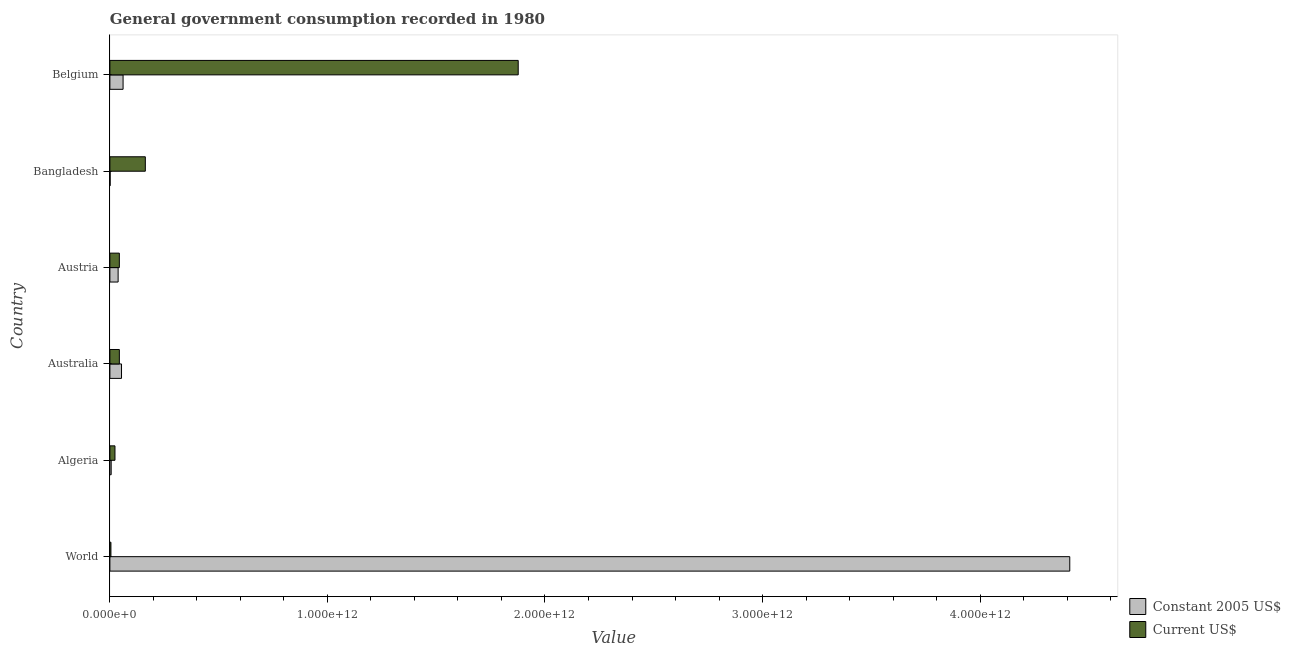How many groups of bars are there?
Keep it short and to the point. 6. How many bars are there on the 2nd tick from the bottom?
Give a very brief answer. 2. What is the label of the 2nd group of bars from the top?
Make the answer very short. Bangladesh. In how many cases, is the number of bars for a given country not equal to the number of legend labels?
Provide a succinct answer. 0. What is the value consumed in current us$ in Algeria?
Your answer should be compact. 2.34e+1. Across all countries, what is the maximum value consumed in constant 2005 us$?
Keep it short and to the point. 4.41e+12. Across all countries, what is the minimum value consumed in current us$?
Your response must be concise. 4.76e+09. In which country was the value consumed in constant 2005 us$ minimum?
Your answer should be compact. Bangladesh. What is the total value consumed in constant 2005 us$ in the graph?
Your answer should be compact. 4.57e+12. What is the difference between the value consumed in current us$ in Austria and that in World?
Provide a short and direct response. 3.87e+1. What is the difference between the value consumed in constant 2005 us$ in Bangladesh and the value consumed in current us$ in Austria?
Ensure brevity in your answer.  -4.23e+1. What is the average value consumed in current us$ per country?
Keep it short and to the point. 3.59e+11. What is the difference between the value consumed in constant 2005 us$ and value consumed in current us$ in Austria?
Keep it short and to the point. -5.59e+09. In how many countries, is the value consumed in constant 2005 us$ greater than 2400000000000 ?
Give a very brief answer. 1. Is the difference between the value consumed in current us$ in Algeria and Belgium greater than the difference between the value consumed in constant 2005 us$ in Algeria and Belgium?
Make the answer very short. No. What is the difference between the highest and the second highest value consumed in current us$?
Your response must be concise. 1.71e+12. What is the difference between the highest and the lowest value consumed in constant 2005 us$?
Your answer should be compact. 4.41e+12. In how many countries, is the value consumed in constant 2005 us$ greater than the average value consumed in constant 2005 us$ taken over all countries?
Ensure brevity in your answer.  1. Is the sum of the value consumed in constant 2005 us$ in Austria and World greater than the maximum value consumed in current us$ across all countries?
Offer a very short reply. Yes. What does the 2nd bar from the top in Belgium represents?
Give a very brief answer. Constant 2005 US$. What does the 1st bar from the bottom in Belgium represents?
Your response must be concise. Constant 2005 US$. How many bars are there?
Provide a succinct answer. 12. What is the difference between two consecutive major ticks on the X-axis?
Offer a terse response. 1.00e+12. Are the values on the major ticks of X-axis written in scientific E-notation?
Offer a terse response. Yes. Does the graph contain any zero values?
Your answer should be very brief. No. Where does the legend appear in the graph?
Ensure brevity in your answer.  Bottom right. How many legend labels are there?
Keep it short and to the point. 2. How are the legend labels stacked?
Provide a short and direct response. Vertical. What is the title of the graph?
Make the answer very short. General government consumption recorded in 1980. What is the label or title of the X-axis?
Offer a terse response. Value. What is the label or title of the Y-axis?
Keep it short and to the point. Country. What is the Value in Constant 2005 US$ in World?
Offer a very short reply. 4.41e+12. What is the Value of Current US$ in World?
Provide a short and direct response. 4.76e+09. What is the Value of Constant 2005 US$ in Algeria?
Offer a very short reply. 5.88e+09. What is the Value of Current US$ in Algeria?
Offer a very short reply. 2.34e+1. What is the Value of Constant 2005 US$ in Australia?
Offer a very short reply. 5.34e+1. What is the Value of Current US$ in Australia?
Make the answer very short. 4.35e+1. What is the Value of Constant 2005 US$ in Austria?
Provide a succinct answer. 3.78e+1. What is the Value of Current US$ in Austria?
Keep it short and to the point. 4.34e+1. What is the Value in Constant 2005 US$ in Bangladesh?
Make the answer very short. 1.09e+09. What is the Value of Current US$ in Bangladesh?
Your answer should be very brief. 1.63e+11. What is the Value of Constant 2005 US$ in Belgium?
Your answer should be compact. 6.06e+1. What is the Value in Current US$ in Belgium?
Offer a terse response. 1.88e+12. Across all countries, what is the maximum Value in Constant 2005 US$?
Your answer should be very brief. 4.41e+12. Across all countries, what is the maximum Value of Current US$?
Offer a very short reply. 1.88e+12. Across all countries, what is the minimum Value in Constant 2005 US$?
Keep it short and to the point. 1.09e+09. Across all countries, what is the minimum Value of Current US$?
Make the answer very short. 4.76e+09. What is the total Value in Constant 2005 US$ in the graph?
Offer a very short reply. 4.57e+12. What is the total Value in Current US$ in the graph?
Make the answer very short. 2.15e+12. What is the difference between the Value of Constant 2005 US$ in World and that in Algeria?
Provide a short and direct response. 4.41e+12. What is the difference between the Value of Current US$ in World and that in Algeria?
Keep it short and to the point. -1.86e+1. What is the difference between the Value of Constant 2005 US$ in World and that in Australia?
Make the answer very short. 4.36e+12. What is the difference between the Value of Current US$ in World and that in Australia?
Make the answer very short. -3.87e+1. What is the difference between the Value in Constant 2005 US$ in World and that in Austria?
Your answer should be very brief. 4.37e+12. What is the difference between the Value of Current US$ in World and that in Austria?
Provide a succinct answer. -3.87e+1. What is the difference between the Value of Constant 2005 US$ in World and that in Bangladesh?
Make the answer very short. 4.41e+12. What is the difference between the Value of Current US$ in World and that in Bangladesh?
Provide a succinct answer. -1.58e+11. What is the difference between the Value of Constant 2005 US$ in World and that in Belgium?
Offer a very short reply. 4.35e+12. What is the difference between the Value of Current US$ in World and that in Belgium?
Provide a succinct answer. -1.87e+12. What is the difference between the Value in Constant 2005 US$ in Algeria and that in Australia?
Your answer should be very brief. -4.75e+1. What is the difference between the Value in Current US$ in Algeria and that in Australia?
Offer a very short reply. -2.01e+1. What is the difference between the Value of Constant 2005 US$ in Algeria and that in Austria?
Offer a very short reply. -3.20e+1. What is the difference between the Value of Current US$ in Algeria and that in Austria?
Offer a very short reply. -2.01e+1. What is the difference between the Value in Constant 2005 US$ in Algeria and that in Bangladesh?
Offer a terse response. 4.78e+09. What is the difference between the Value in Current US$ in Algeria and that in Bangladesh?
Offer a very short reply. -1.40e+11. What is the difference between the Value of Constant 2005 US$ in Algeria and that in Belgium?
Make the answer very short. -5.47e+1. What is the difference between the Value of Current US$ in Algeria and that in Belgium?
Provide a short and direct response. -1.85e+12. What is the difference between the Value of Constant 2005 US$ in Australia and that in Austria?
Your answer should be very brief. 1.56e+1. What is the difference between the Value of Current US$ in Australia and that in Austria?
Offer a terse response. 6.97e+07. What is the difference between the Value of Constant 2005 US$ in Australia and that in Bangladesh?
Your answer should be very brief. 5.23e+1. What is the difference between the Value of Current US$ in Australia and that in Bangladesh?
Offer a very short reply. -1.19e+11. What is the difference between the Value in Constant 2005 US$ in Australia and that in Belgium?
Offer a terse response. -7.18e+09. What is the difference between the Value in Current US$ in Australia and that in Belgium?
Offer a very short reply. -1.83e+12. What is the difference between the Value in Constant 2005 US$ in Austria and that in Bangladesh?
Provide a short and direct response. 3.67e+1. What is the difference between the Value in Current US$ in Austria and that in Bangladesh?
Make the answer very short. -1.19e+11. What is the difference between the Value of Constant 2005 US$ in Austria and that in Belgium?
Your answer should be very brief. -2.27e+1. What is the difference between the Value of Current US$ in Austria and that in Belgium?
Give a very brief answer. -1.83e+12. What is the difference between the Value of Constant 2005 US$ in Bangladesh and that in Belgium?
Keep it short and to the point. -5.95e+1. What is the difference between the Value of Current US$ in Bangladesh and that in Belgium?
Your answer should be compact. -1.71e+12. What is the difference between the Value of Constant 2005 US$ in World and the Value of Current US$ in Algeria?
Your response must be concise. 4.39e+12. What is the difference between the Value in Constant 2005 US$ in World and the Value in Current US$ in Australia?
Your answer should be compact. 4.37e+12. What is the difference between the Value of Constant 2005 US$ in World and the Value of Current US$ in Austria?
Provide a short and direct response. 4.37e+12. What is the difference between the Value of Constant 2005 US$ in World and the Value of Current US$ in Bangladesh?
Make the answer very short. 4.25e+12. What is the difference between the Value in Constant 2005 US$ in World and the Value in Current US$ in Belgium?
Your answer should be very brief. 2.54e+12. What is the difference between the Value of Constant 2005 US$ in Algeria and the Value of Current US$ in Australia?
Give a very brief answer. -3.76e+1. What is the difference between the Value of Constant 2005 US$ in Algeria and the Value of Current US$ in Austria?
Your response must be concise. -3.76e+1. What is the difference between the Value in Constant 2005 US$ in Algeria and the Value in Current US$ in Bangladesh?
Ensure brevity in your answer.  -1.57e+11. What is the difference between the Value of Constant 2005 US$ in Algeria and the Value of Current US$ in Belgium?
Give a very brief answer. -1.87e+12. What is the difference between the Value of Constant 2005 US$ in Australia and the Value of Current US$ in Austria?
Provide a succinct answer. 9.97e+09. What is the difference between the Value in Constant 2005 US$ in Australia and the Value in Current US$ in Bangladesh?
Make the answer very short. -1.09e+11. What is the difference between the Value of Constant 2005 US$ in Australia and the Value of Current US$ in Belgium?
Your answer should be very brief. -1.82e+12. What is the difference between the Value in Constant 2005 US$ in Austria and the Value in Current US$ in Bangladesh?
Offer a terse response. -1.25e+11. What is the difference between the Value of Constant 2005 US$ in Austria and the Value of Current US$ in Belgium?
Offer a very short reply. -1.84e+12. What is the difference between the Value in Constant 2005 US$ in Bangladesh and the Value in Current US$ in Belgium?
Your response must be concise. -1.88e+12. What is the average Value in Constant 2005 US$ per country?
Your answer should be very brief. 7.62e+11. What is the average Value in Current US$ per country?
Your answer should be compact. 3.59e+11. What is the difference between the Value of Constant 2005 US$ and Value of Current US$ in World?
Ensure brevity in your answer.  4.41e+12. What is the difference between the Value in Constant 2005 US$ and Value in Current US$ in Algeria?
Make the answer very short. -1.75e+1. What is the difference between the Value of Constant 2005 US$ and Value of Current US$ in Australia?
Make the answer very short. 9.90e+09. What is the difference between the Value of Constant 2005 US$ and Value of Current US$ in Austria?
Your response must be concise. -5.59e+09. What is the difference between the Value of Constant 2005 US$ and Value of Current US$ in Bangladesh?
Your response must be concise. -1.62e+11. What is the difference between the Value of Constant 2005 US$ and Value of Current US$ in Belgium?
Your response must be concise. -1.82e+12. What is the ratio of the Value in Constant 2005 US$ in World to that in Algeria?
Your answer should be compact. 750.75. What is the ratio of the Value of Current US$ in World to that in Algeria?
Make the answer very short. 0.2. What is the ratio of the Value of Constant 2005 US$ in World to that in Australia?
Your answer should be compact. 82.63. What is the ratio of the Value of Current US$ in World to that in Australia?
Offer a terse response. 0.11. What is the ratio of the Value in Constant 2005 US$ in World to that in Austria?
Keep it short and to the point. 116.62. What is the ratio of the Value in Current US$ in World to that in Austria?
Your answer should be very brief. 0.11. What is the ratio of the Value of Constant 2005 US$ in World to that in Bangladesh?
Your response must be concise. 4035.72. What is the ratio of the Value in Current US$ in World to that in Bangladesh?
Offer a terse response. 0.03. What is the ratio of the Value of Constant 2005 US$ in World to that in Belgium?
Keep it short and to the point. 72.83. What is the ratio of the Value in Current US$ in World to that in Belgium?
Offer a terse response. 0. What is the ratio of the Value in Constant 2005 US$ in Algeria to that in Australia?
Your answer should be compact. 0.11. What is the ratio of the Value in Current US$ in Algeria to that in Australia?
Your response must be concise. 0.54. What is the ratio of the Value in Constant 2005 US$ in Algeria to that in Austria?
Your response must be concise. 0.16. What is the ratio of the Value in Current US$ in Algeria to that in Austria?
Make the answer very short. 0.54. What is the ratio of the Value of Constant 2005 US$ in Algeria to that in Bangladesh?
Provide a short and direct response. 5.38. What is the ratio of the Value of Current US$ in Algeria to that in Bangladesh?
Your answer should be very brief. 0.14. What is the ratio of the Value of Constant 2005 US$ in Algeria to that in Belgium?
Your response must be concise. 0.1. What is the ratio of the Value in Current US$ in Algeria to that in Belgium?
Your answer should be very brief. 0.01. What is the ratio of the Value in Constant 2005 US$ in Australia to that in Austria?
Provide a succinct answer. 1.41. What is the ratio of the Value in Constant 2005 US$ in Australia to that in Bangladesh?
Your answer should be very brief. 48.84. What is the ratio of the Value of Current US$ in Australia to that in Bangladesh?
Your answer should be compact. 0.27. What is the ratio of the Value of Constant 2005 US$ in Australia to that in Belgium?
Ensure brevity in your answer.  0.88. What is the ratio of the Value in Current US$ in Australia to that in Belgium?
Keep it short and to the point. 0.02. What is the ratio of the Value in Constant 2005 US$ in Austria to that in Bangladesh?
Provide a succinct answer. 34.61. What is the ratio of the Value in Current US$ in Austria to that in Bangladesh?
Ensure brevity in your answer.  0.27. What is the ratio of the Value in Constant 2005 US$ in Austria to that in Belgium?
Offer a terse response. 0.62. What is the ratio of the Value in Current US$ in Austria to that in Belgium?
Make the answer very short. 0.02. What is the ratio of the Value in Constant 2005 US$ in Bangladesh to that in Belgium?
Provide a succinct answer. 0.02. What is the ratio of the Value in Current US$ in Bangladesh to that in Belgium?
Offer a terse response. 0.09. What is the difference between the highest and the second highest Value of Constant 2005 US$?
Provide a succinct answer. 4.35e+12. What is the difference between the highest and the second highest Value of Current US$?
Give a very brief answer. 1.71e+12. What is the difference between the highest and the lowest Value in Constant 2005 US$?
Your answer should be very brief. 4.41e+12. What is the difference between the highest and the lowest Value of Current US$?
Ensure brevity in your answer.  1.87e+12. 